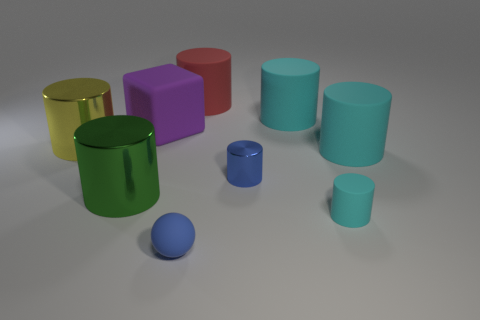The big cyan rubber object in front of the big yellow object has what shape?
Provide a succinct answer. Cylinder. Is there a large red object made of the same material as the small ball?
Your answer should be very brief. Yes. There is a small rubber thing that is left of the blue cylinder; is it the same color as the tiny metallic cylinder?
Provide a succinct answer. Yes. The blue cylinder is what size?
Provide a succinct answer. Small. Are there any big cyan objects to the right of the small cylinder on the left side of the cyan cylinder that is in front of the tiny blue shiny thing?
Provide a succinct answer. Yes. There is a large purple rubber object; what number of cylinders are behind it?
Keep it short and to the point. 2. What number of cylinders have the same color as the small rubber ball?
Your response must be concise. 1. How many things are either big rubber cylinders to the left of the small cyan matte object or tiny blue objects that are in front of the green object?
Provide a short and direct response. 3. Is the number of large red objects greater than the number of small blue objects?
Your answer should be very brief. No. There is a large matte object that is right of the small rubber cylinder; what is its color?
Your answer should be compact. Cyan. 